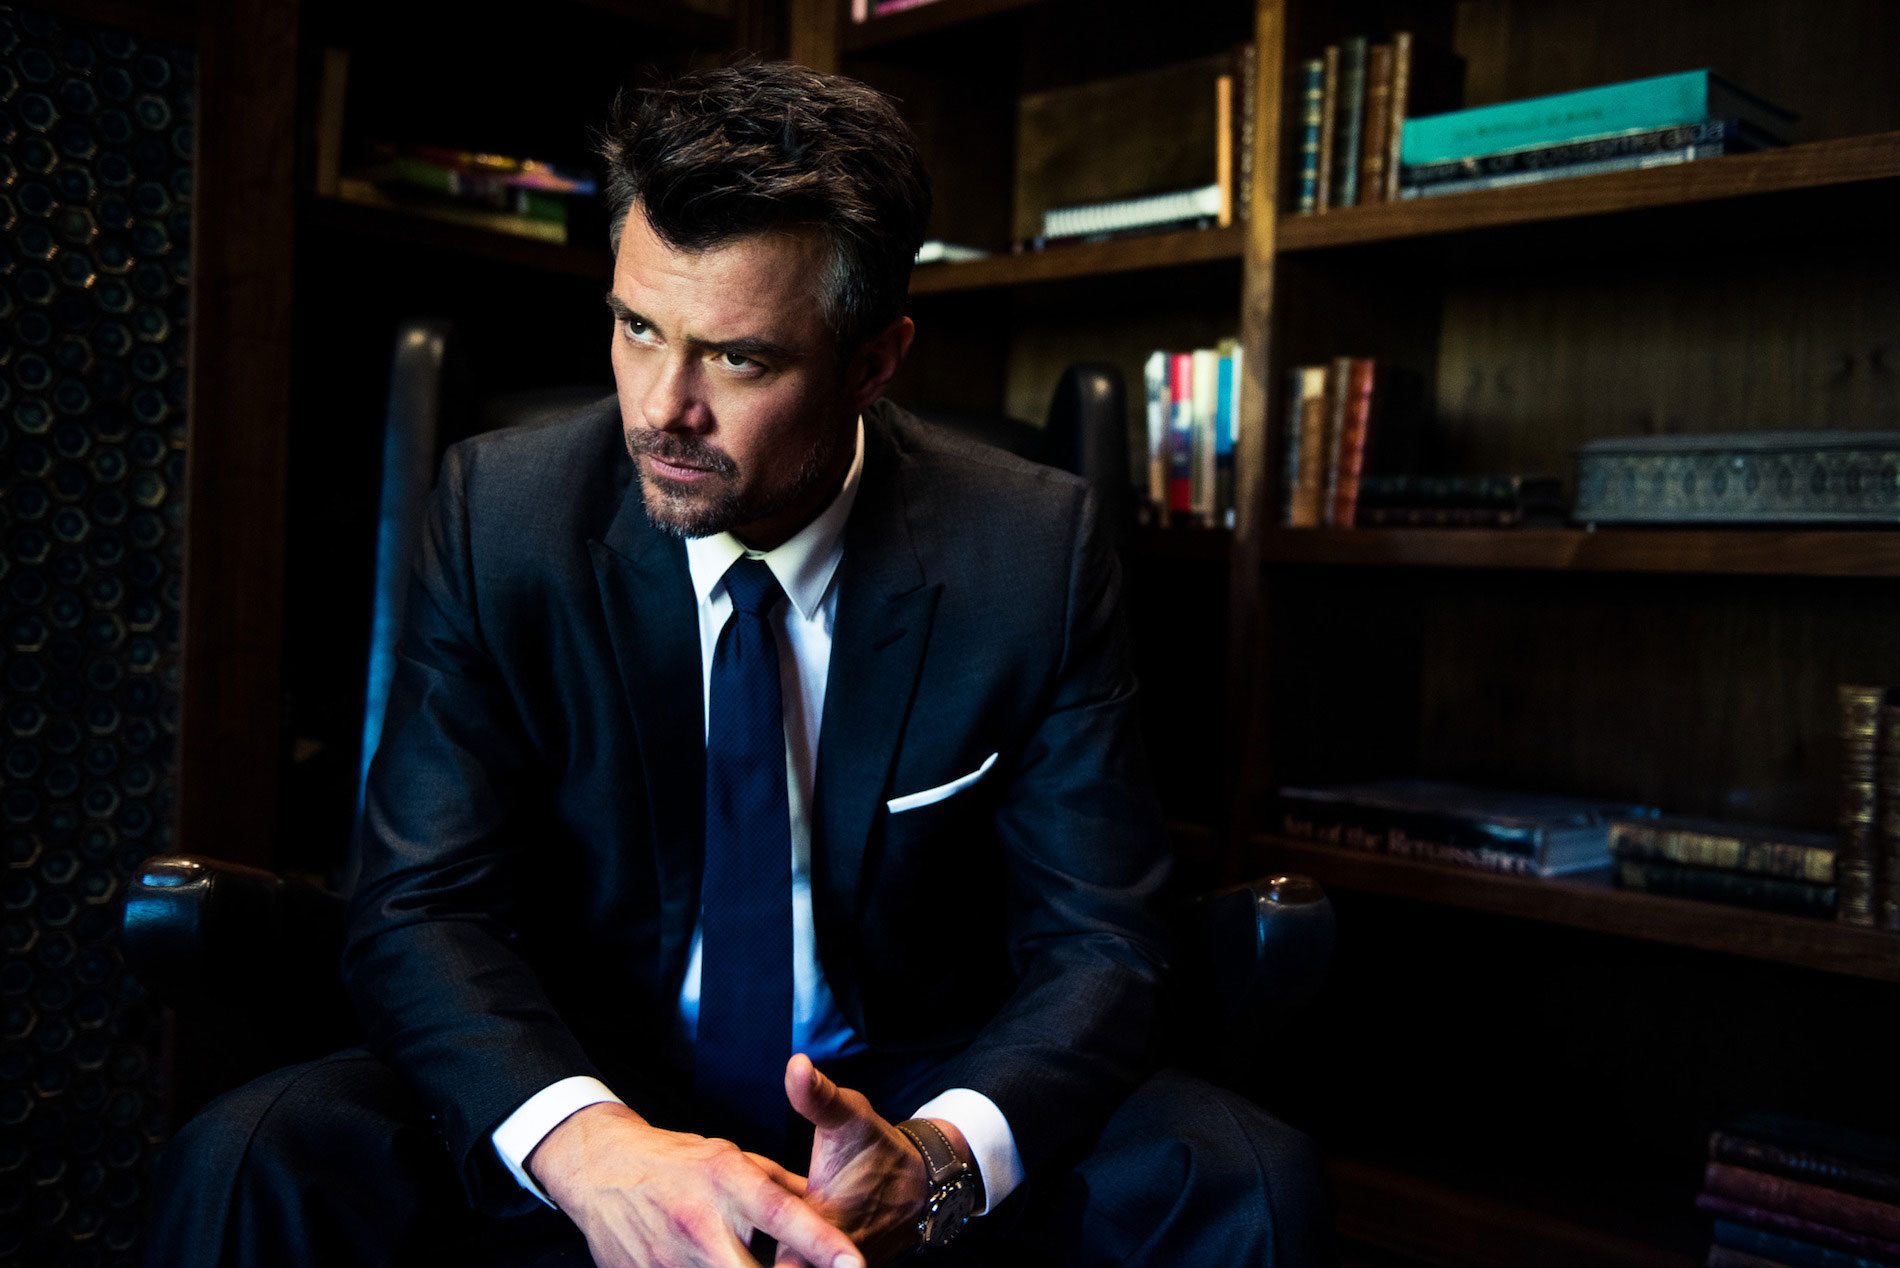What does the man's body language tell us about his mood or thoughts in this moment? The man's body language, with his hands clasped and eyes looking away, suggests he is deep in thought or possibly dealing with a moment of decision or contemplation. His slightly furrowed brow and the overall relaxed posture might imply a serene yet serious deliberation on important matters. 